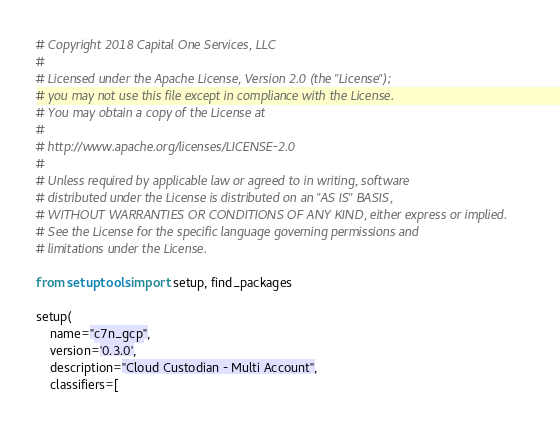Convert code to text. <code><loc_0><loc_0><loc_500><loc_500><_Python_># Copyright 2018 Capital One Services, LLC
#
# Licensed under the Apache License, Version 2.0 (the "License");
# you may not use this file except in compliance with the License.
# You may obtain a copy of the License at
#
# http://www.apache.org/licenses/LICENSE-2.0
#
# Unless required by applicable law or agreed to in writing, software
# distributed under the License is distributed on an "AS IS" BASIS,
# WITHOUT WARRANTIES OR CONDITIONS OF ANY KIND, either express or implied.
# See the License for the specific language governing permissions and
# limitations under the License.

from setuptools import setup, find_packages

setup(
    name="c7n_gcp",
    version='0.3.0',
    description="Cloud Custodian - Multi Account",
    classifiers=[</code> 